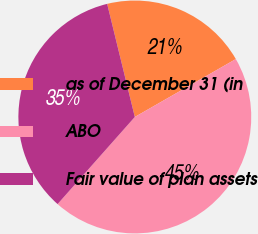<chart> <loc_0><loc_0><loc_500><loc_500><pie_chart><fcel>as of December 31 (in<fcel>ABO<fcel>Fair value of plan assets<nl><fcel>20.53%<fcel>44.83%<fcel>34.64%<nl></chart> 